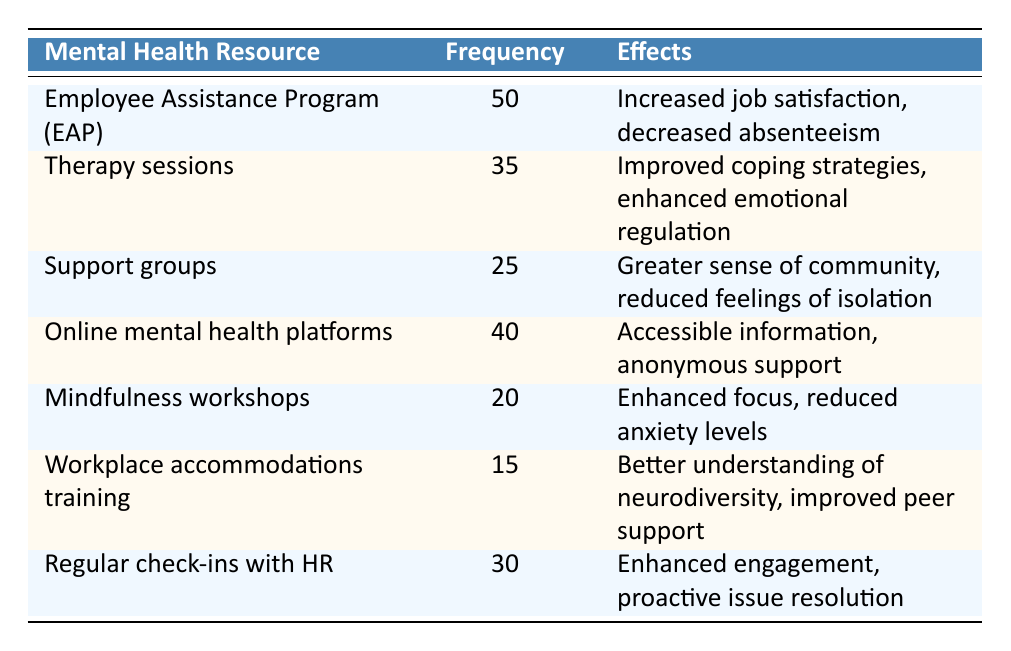What is the frequency of the Employee Assistance Program (EAP) usage? The table states that the frequency for the Employee Assistance Program (EAP) is 50.
Answer: 50 How many employees utilized therapy sessions? According to the table, the frequency of therapy sessions utilized is 35.
Answer: 35 Which resource has the lowest frequency of usage? By examining the table, it shows that the Workplace Accommodations Training has the lowest frequency at 15.
Answer: Workplace Accommodations Training Is the frequency of online mental health platforms higher than that of support groups? The frequency for online mental health platforms is 40, while support groups have a frequency of 25, making it true that online mental health platforms has a higher frequency.
Answer: Yes What is the total frequency of all the mental health resources used? To find the total, sum the frequencies: 50 + 35 + 25 + 40 + 20 + 15 + 30 = 215.
Answer: 215 What is the average usage frequency of all the listed mental health resources? There are 7 resources listed, and the total frequency is 215. To find the average, divide 215 by 7. The calculation shows that the average usage frequency is approximately 30.71.
Answer: 30.71 Are regular check-ins with HR associated with higher usage compared to mindfulness workshops? Regular check-ins with HR have a frequency of 30, and mindfulness workshops have a frequency of 20. Since 30 is greater than 20, the statement is true.
Answer: Yes If support groups were to increase by 5 in frequency, what would be their new total? The current frequency of support groups is 25. After adding 5, the new total would be 25 + 5 = 30.
Answer: 30 Which resource has effects described as "better understanding of neurodiversity"? The table shows that the effects of the Workplace Accommodations Training include a better understanding of neurodiversity.
Answer: Workplace Accommodations Training What is the difference in frequency between the most used and least used mental health resources? The most used resource, the Employee Assistance Program (EAP), has a frequency of 50, while the least used, Workplace Accommodations Training, has a frequency of 15. Therefore, the difference is 50 - 15 = 35.
Answer: 35 